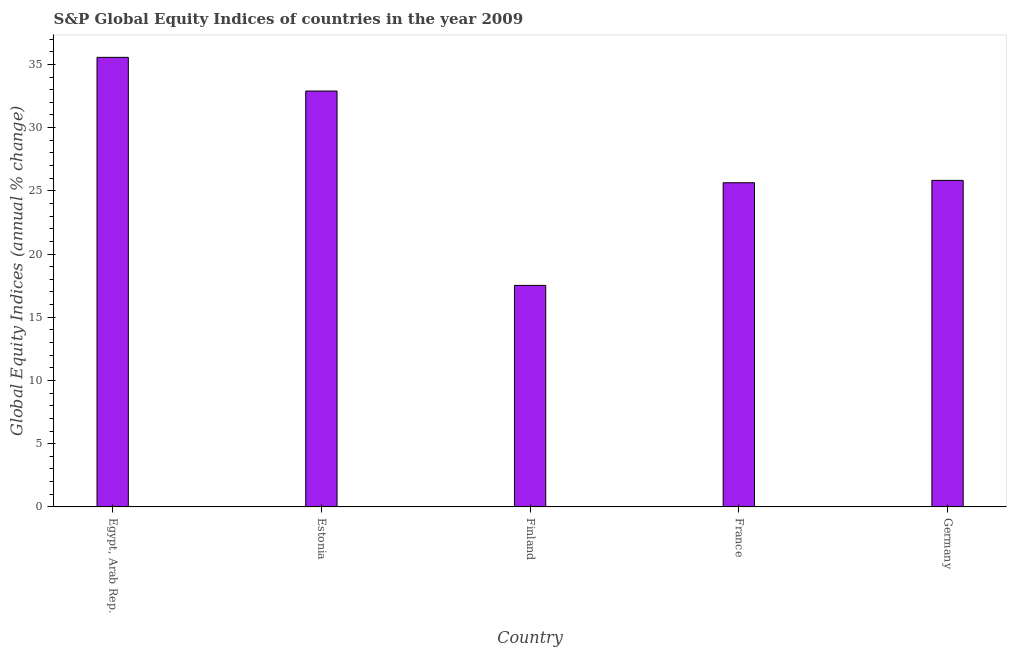Does the graph contain any zero values?
Your answer should be compact. No. What is the title of the graph?
Your answer should be compact. S&P Global Equity Indices of countries in the year 2009. What is the label or title of the X-axis?
Provide a succinct answer. Country. What is the label or title of the Y-axis?
Keep it short and to the point. Global Equity Indices (annual % change). What is the s&p global equity indices in Estonia?
Make the answer very short. 32.89. Across all countries, what is the maximum s&p global equity indices?
Give a very brief answer. 35.55. Across all countries, what is the minimum s&p global equity indices?
Provide a succinct answer. 17.52. In which country was the s&p global equity indices maximum?
Make the answer very short. Egypt, Arab Rep. In which country was the s&p global equity indices minimum?
Provide a short and direct response. Finland. What is the sum of the s&p global equity indices?
Your response must be concise. 137.43. What is the difference between the s&p global equity indices in Estonia and France?
Ensure brevity in your answer.  7.25. What is the average s&p global equity indices per country?
Give a very brief answer. 27.48. What is the median s&p global equity indices?
Give a very brief answer. 25.82. What is the ratio of the s&p global equity indices in Finland to that in France?
Offer a terse response. 0.68. Is the s&p global equity indices in Egypt, Arab Rep. less than that in Germany?
Provide a succinct answer. No. Is the difference between the s&p global equity indices in Egypt, Arab Rep. and Finland greater than the difference between any two countries?
Your answer should be very brief. Yes. What is the difference between the highest and the second highest s&p global equity indices?
Provide a succinct answer. 2.66. What is the difference between the highest and the lowest s&p global equity indices?
Give a very brief answer. 18.03. In how many countries, is the s&p global equity indices greater than the average s&p global equity indices taken over all countries?
Your answer should be compact. 2. How many bars are there?
Provide a succinct answer. 5. Are all the bars in the graph horizontal?
Provide a succinct answer. No. What is the difference between two consecutive major ticks on the Y-axis?
Give a very brief answer. 5. What is the Global Equity Indices (annual % change) in Egypt, Arab Rep.?
Make the answer very short. 35.55. What is the Global Equity Indices (annual % change) of Estonia?
Give a very brief answer. 32.89. What is the Global Equity Indices (annual % change) of Finland?
Provide a succinct answer. 17.52. What is the Global Equity Indices (annual % change) in France?
Keep it short and to the point. 25.64. What is the Global Equity Indices (annual % change) in Germany?
Offer a very short reply. 25.82. What is the difference between the Global Equity Indices (annual % change) in Egypt, Arab Rep. and Estonia?
Your answer should be compact. 2.66. What is the difference between the Global Equity Indices (annual % change) in Egypt, Arab Rep. and Finland?
Your answer should be compact. 18.03. What is the difference between the Global Equity Indices (annual % change) in Egypt, Arab Rep. and France?
Make the answer very short. 9.92. What is the difference between the Global Equity Indices (annual % change) in Egypt, Arab Rep. and Germany?
Your answer should be compact. 9.73. What is the difference between the Global Equity Indices (annual % change) in Estonia and Finland?
Give a very brief answer. 15.37. What is the difference between the Global Equity Indices (annual % change) in Estonia and France?
Provide a short and direct response. 7.25. What is the difference between the Global Equity Indices (annual % change) in Estonia and Germany?
Your response must be concise. 7.07. What is the difference between the Global Equity Indices (annual % change) in Finland and France?
Give a very brief answer. -8.12. What is the difference between the Global Equity Indices (annual % change) in Finland and Germany?
Offer a very short reply. -8.3. What is the difference between the Global Equity Indices (annual % change) in France and Germany?
Offer a very short reply. -0.19. What is the ratio of the Global Equity Indices (annual % change) in Egypt, Arab Rep. to that in Estonia?
Your answer should be very brief. 1.08. What is the ratio of the Global Equity Indices (annual % change) in Egypt, Arab Rep. to that in Finland?
Your answer should be compact. 2.03. What is the ratio of the Global Equity Indices (annual % change) in Egypt, Arab Rep. to that in France?
Your answer should be very brief. 1.39. What is the ratio of the Global Equity Indices (annual % change) in Egypt, Arab Rep. to that in Germany?
Your response must be concise. 1.38. What is the ratio of the Global Equity Indices (annual % change) in Estonia to that in Finland?
Your answer should be very brief. 1.88. What is the ratio of the Global Equity Indices (annual % change) in Estonia to that in France?
Your response must be concise. 1.28. What is the ratio of the Global Equity Indices (annual % change) in Estonia to that in Germany?
Provide a succinct answer. 1.27. What is the ratio of the Global Equity Indices (annual % change) in Finland to that in France?
Your answer should be very brief. 0.68. What is the ratio of the Global Equity Indices (annual % change) in Finland to that in Germany?
Offer a terse response. 0.68. 